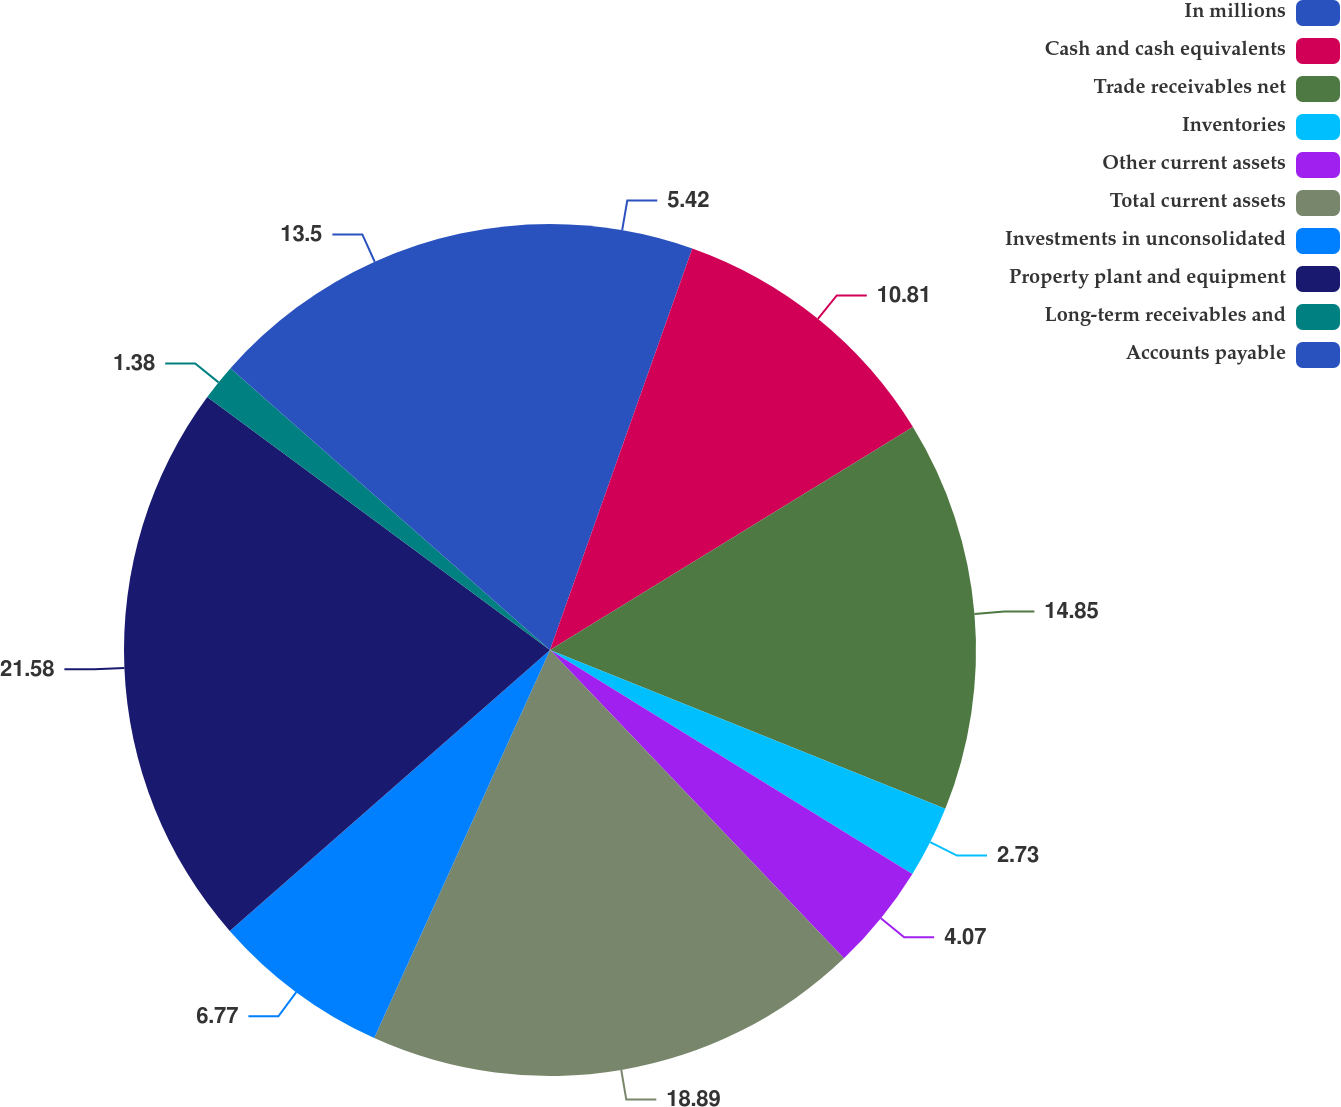Convert chart to OTSL. <chart><loc_0><loc_0><loc_500><loc_500><pie_chart><fcel>In millions<fcel>Cash and cash equivalents<fcel>Trade receivables net<fcel>Inventories<fcel>Other current assets<fcel>Total current assets<fcel>Investments in unconsolidated<fcel>Property plant and equipment<fcel>Long-term receivables and<fcel>Accounts payable<nl><fcel>5.42%<fcel>10.81%<fcel>14.85%<fcel>2.73%<fcel>4.07%<fcel>18.89%<fcel>6.77%<fcel>21.58%<fcel>1.38%<fcel>13.5%<nl></chart> 